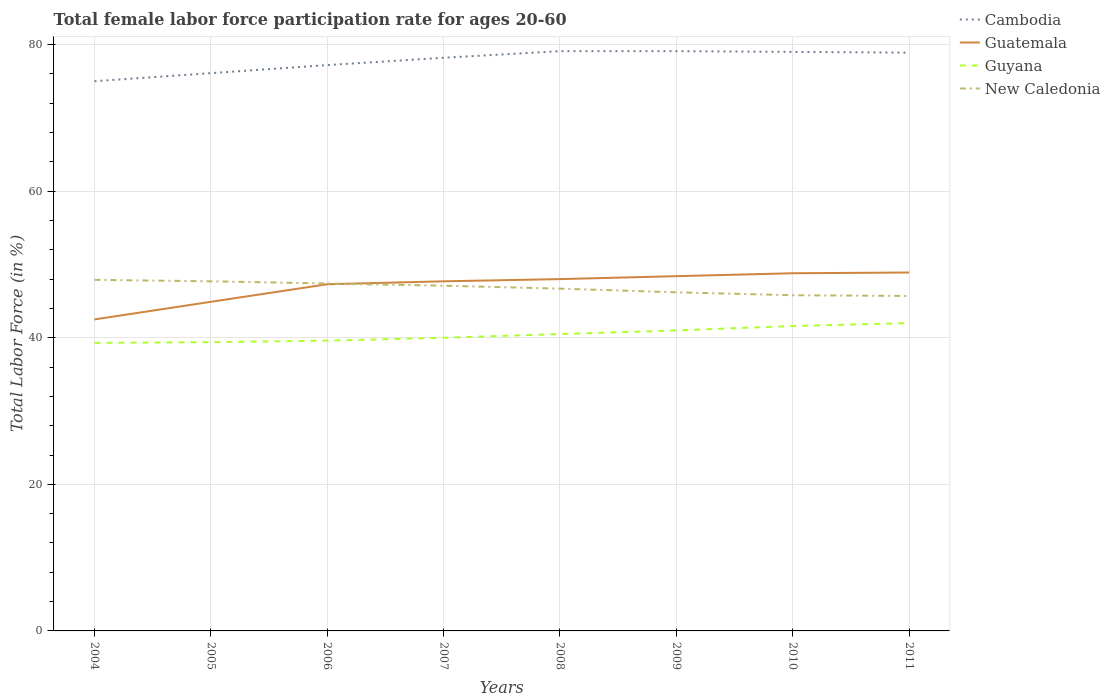Is the number of lines equal to the number of legend labels?
Give a very brief answer. Yes. Across all years, what is the maximum female labor force participation rate in Cambodia?
Make the answer very short. 75. What is the difference between the highest and the second highest female labor force participation rate in New Caledonia?
Your response must be concise. 2.2. What is the difference between the highest and the lowest female labor force participation rate in Guyana?
Offer a very short reply. 4. Is the female labor force participation rate in Guatemala strictly greater than the female labor force participation rate in Guyana over the years?
Your answer should be compact. No. How many lines are there?
Keep it short and to the point. 4. How many years are there in the graph?
Make the answer very short. 8. What is the difference between two consecutive major ticks on the Y-axis?
Keep it short and to the point. 20. Are the values on the major ticks of Y-axis written in scientific E-notation?
Offer a terse response. No. Does the graph contain grids?
Your answer should be very brief. Yes. Where does the legend appear in the graph?
Your answer should be compact. Top right. What is the title of the graph?
Keep it short and to the point. Total female labor force participation rate for ages 20-60. Does "Central Europe" appear as one of the legend labels in the graph?
Make the answer very short. No. What is the Total Labor Force (in %) in Cambodia in 2004?
Provide a succinct answer. 75. What is the Total Labor Force (in %) of Guatemala in 2004?
Offer a terse response. 42.5. What is the Total Labor Force (in %) in Guyana in 2004?
Make the answer very short. 39.3. What is the Total Labor Force (in %) of New Caledonia in 2004?
Offer a terse response. 47.9. What is the Total Labor Force (in %) in Cambodia in 2005?
Keep it short and to the point. 76.1. What is the Total Labor Force (in %) of Guatemala in 2005?
Your response must be concise. 44.9. What is the Total Labor Force (in %) in Guyana in 2005?
Ensure brevity in your answer.  39.4. What is the Total Labor Force (in %) in New Caledonia in 2005?
Your answer should be very brief. 47.7. What is the Total Labor Force (in %) of Cambodia in 2006?
Your answer should be very brief. 77.2. What is the Total Labor Force (in %) in Guatemala in 2006?
Your answer should be compact. 47.3. What is the Total Labor Force (in %) in Guyana in 2006?
Your answer should be compact. 39.6. What is the Total Labor Force (in %) of New Caledonia in 2006?
Offer a terse response. 47.4. What is the Total Labor Force (in %) of Cambodia in 2007?
Offer a terse response. 78.2. What is the Total Labor Force (in %) of Guatemala in 2007?
Your response must be concise. 47.7. What is the Total Labor Force (in %) in New Caledonia in 2007?
Provide a succinct answer. 47.1. What is the Total Labor Force (in %) in Cambodia in 2008?
Ensure brevity in your answer.  79.1. What is the Total Labor Force (in %) of Guatemala in 2008?
Make the answer very short. 48. What is the Total Labor Force (in %) in Guyana in 2008?
Your answer should be very brief. 40.5. What is the Total Labor Force (in %) of New Caledonia in 2008?
Provide a short and direct response. 46.7. What is the Total Labor Force (in %) in Cambodia in 2009?
Ensure brevity in your answer.  79.1. What is the Total Labor Force (in %) of Guatemala in 2009?
Give a very brief answer. 48.4. What is the Total Labor Force (in %) of New Caledonia in 2009?
Provide a short and direct response. 46.2. What is the Total Labor Force (in %) in Cambodia in 2010?
Offer a very short reply. 79. What is the Total Labor Force (in %) of Guatemala in 2010?
Provide a short and direct response. 48.8. What is the Total Labor Force (in %) in Guyana in 2010?
Your answer should be compact. 41.6. What is the Total Labor Force (in %) of New Caledonia in 2010?
Your answer should be compact. 45.8. What is the Total Labor Force (in %) in Cambodia in 2011?
Provide a succinct answer. 78.9. What is the Total Labor Force (in %) of Guatemala in 2011?
Make the answer very short. 48.9. What is the Total Labor Force (in %) of Guyana in 2011?
Your answer should be compact. 42. What is the Total Labor Force (in %) in New Caledonia in 2011?
Provide a succinct answer. 45.7. Across all years, what is the maximum Total Labor Force (in %) in Cambodia?
Your answer should be very brief. 79.1. Across all years, what is the maximum Total Labor Force (in %) in Guatemala?
Offer a very short reply. 48.9. Across all years, what is the maximum Total Labor Force (in %) of Guyana?
Provide a succinct answer. 42. Across all years, what is the maximum Total Labor Force (in %) in New Caledonia?
Your answer should be very brief. 47.9. Across all years, what is the minimum Total Labor Force (in %) in Cambodia?
Provide a succinct answer. 75. Across all years, what is the minimum Total Labor Force (in %) in Guatemala?
Your answer should be very brief. 42.5. Across all years, what is the minimum Total Labor Force (in %) in Guyana?
Your answer should be very brief. 39.3. Across all years, what is the minimum Total Labor Force (in %) of New Caledonia?
Your answer should be compact. 45.7. What is the total Total Labor Force (in %) in Cambodia in the graph?
Provide a short and direct response. 622.6. What is the total Total Labor Force (in %) of Guatemala in the graph?
Provide a succinct answer. 376.5. What is the total Total Labor Force (in %) of Guyana in the graph?
Provide a succinct answer. 323.4. What is the total Total Labor Force (in %) in New Caledonia in the graph?
Offer a terse response. 374.5. What is the difference between the Total Labor Force (in %) of Guyana in 2004 and that in 2005?
Offer a very short reply. -0.1. What is the difference between the Total Labor Force (in %) in New Caledonia in 2004 and that in 2005?
Your response must be concise. 0.2. What is the difference between the Total Labor Force (in %) in Cambodia in 2004 and that in 2006?
Give a very brief answer. -2.2. What is the difference between the Total Labor Force (in %) in New Caledonia in 2004 and that in 2007?
Offer a very short reply. 0.8. What is the difference between the Total Labor Force (in %) of Guatemala in 2004 and that in 2008?
Your response must be concise. -5.5. What is the difference between the Total Labor Force (in %) in New Caledonia in 2004 and that in 2008?
Provide a short and direct response. 1.2. What is the difference between the Total Labor Force (in %) of Cambodia in 2004 and that in 2009?
Provide a succinct answer. -4.1. What is the difference between the Total Labor Force (in %) of Cambodia in 2004 and that in 2010?
Your answer should be compact. -4. What is the difference between the Total Labor Force (in %) in New Caledonia in 2004 and that in 2010?
Ensure brevity in your answer.  2.1. What is the difference between the Total Labor Force (in %) of Cambodia in 2004 and that in 2011?
Ensure brevity in your answer.  -3.9. What is the difference between the Total Labor Force (in %) in Guatemala in 2004 and that in 2011?
Offer a terse response. -6.4. What is the difference between the Total Labor Force (in %) in New Caledonia in 2004 and that in 2011?
Offer a very short reply. 2.2. What is the difference between the Total Labor Force (in %) in Guatemala in 2005 and that in 2006?
Offer a very short reply. -2.4. What is the difference between the Total Labor Force (in %) in Guyana in 2005 and that in 2006?
Your response must be concise. -0.2. What is the difference between the Total Labor Force (in %) of New Caledonia in 2005 and that in 2007?
Make the answer very short. 0.6. What is the difference between the Total Labor Force (in %) in Cambodia in 2005 and that in 2008?
Provide a succinct answer. -3. What is the difference between the Total Labor Force (in %) in Guyana in 2005 and that in 2008?
Your response must be concise. -1.1. What is the difference between the Total Labor Force (in %) of Guatemala in 2005 and that in 2009?
Provide a succinct answer. -3.5. What is the difference between the Total Labor Force (in %) of Guyana in 2005 and that in 2009?
Ensure brevity in your answer.  -1.6. What is the difference between the Total Labor Force (in %) of New Caledonia in 2005 and that in 2009?
Provide a short and direct response. 1.5. What is the difference between the Total Labor Force (in %) in Guatemala in 2005 and that in 2010?
Your answer should be very brief. -3.9. What is the difference between the Total Labor Force (in %) in New Caledonia in 2005 and that in 2010?
Your response must be concise. 1.9. What is the difference between the Total Labor Force (in %) of Cambodia in 2005 and that in 2011?
Provide a short and direct response. -2.8. What is the difference between the Total Labor Force (in %) of New Caledonia in 2005 and that in 2011?
Make the answer very short. 2. What is the difference between the Total Labor Force (in %) of Guatemala in 2006 and that in 2007?
Ensure brevity in your answer.  -0.4. What is the difference between the Total Labor Force (in %) in Cambodia in 2006 and that in 2008?
Offer a terse response. -1.9. What is the difference between the Total Labor Force (in %) of Cambodia in 2006 and that in 2009?
Give a very brief answer. -1.9. What is the difference between the Total Labor Force (in %) in Guatemala in 2006 and that in 2009?
Offer a terse response. -1.1. What is the difference between the Total Labor Force (in %) in New Caledonia in 2006 and that in 2009?
Ensure brevity in your answer.  1.2. What is the difference between the Total Labor Force (in %) of Cambodia in 2006 and that in 2010?
Give a very brief answer. -1.8. What is the difference between the Total Labor Force (in %) in Guatemala in 2006 and that in 2010?
Provide a succinct answer. -1.5. What is the difference between the Total Labor Force (in %) of Guyana in 2006 and that in 2010?
Offer a terse response. -2. What is the difference between the Total Labor Force (in %) in Cambodia in 2006 and that in 2011?
Provide a succinct answer. -1.7. What is the difference between the Total Labor Force (in %) in Guatemala in 2006 and that in 2011?
Your answer should be compact. -1.6. What is the difference between the Total Labor Force (in %) in Cambodia in 2007 and that in 2009?
Your answer should be very brief. -0.9. What is the difference between the Total Labor Force (in %) in Guatemala in 2007 and that in 2009?
Give a very brief answer. -0.7. What is the difference between the Total Labor Force (in %) of Guyana in 2007 and that in 2009?
Provide a short and direct response. -1. What is the difference between the Total Labor Force (in %) in New Caledonia in 2007 and that in 2010?
Your answer should be compact. 1.3. What is the difference between the Total Labor Force (in %) of Guyana in 2008 and that in 2010?
Give a very brief answer. -1.1. What is the difference between the Total Labor Force (in %) in Cambodia in 2008 and that in 2011?
Your answer should be compact. 0.2. What is the difference between the Total Labor Force (in %) of New Caledonia in 2008 and that in 2011?
Your answer should be compact. 1. What is the difference between the Total Labor Force (in %) in Cambodia in 2009 and that in 2010?
Make the answer very short. 0.1. What is the difference between the Total Labor Force (in %) of Cambodia in 2009 and that in 2011?
Make the answer very short. 0.2. What is the difference between the Total Labor Force (in %) in Guyana in 2009 and that in 2011?
Your response must be concise. -1. What is the difference between the Total Labor Force (in %) in Cambodia in 2010 and that in 2011?
Ensure brevity in your answer.  0.1. What is the difference between the Total Labor Force (in %) of Cambodia in 2004 and the Total Labor Force (in %) of Guatemala in 2005?
Give a very brief answer. 30.1. What is the difference between the Total Labor Force (in %) of Cambodia in 2004 and the Total Labor Force (in %) of Guyana in 2005?
Your response must be concise. 35.6. What is the difference between the Total Labor Force (in %) of Cambodia in 2004 and the Total Labor Force (in %) of New Caledonia in 2005?
Ensure brevity in your answer.  27.3. What is the difference between the Total Labor Force (in %) in Guatemala in 2004 and the Total Labor Force (in %) in Guyana in 2005?
Make the answer very short. 3.1. What is the difference between the Total Labor Force (in %) of Cambodia in 2004 and the Total Labor Force (in %) of Guatemala in 2006?
Ensure brevity in your answer.  27.7. What is the difference between the Total Labor Force (in %) of Cambodia in 2004 and the Total Labor Force (in %) of Guyana in 2006?
Give a very brief answer. 35.4. What is the difference between the Total Labor Force (in %) in Cambodia in 2004 and the Total Labor Force (in %) in New Caledonia in 2006?
Give a very brief answer. 27.6. What is the difference between the Total Labor Force (in %) of Guatemala in 2004 and the Total Labor Force (in %) of Guyana in 2006?
Provide a short and direct response. 2.9. What is the difference between the Total Labor Force (in %) in Cambodia in 2004 and the Total Labor Force (in %) in Guatemala in 2007?
Make the answer very short. 27.3. What is the difference between the Total Labor Force (in %) in Cambodia in 2004 and the Total Labor Force (in %) in Guyana in 2007?
Provide a short and direct response. 35. What is the difference between the Total Labor Force (in %) in Cambodia in 2004 and the Total Labor Force (in %) in New Caledonia in 2007?
Make the answer very short. 27.9. What is the difference between the Total Labor Force (in %) of Cambodia in 2004 and the Total Labor Force (in %) of Guatemala in 2008?
Offer a very short reply. 27. What is the difference between the Total Labor Force (in %) of Cambodia in 2004 and the Total Labor Force (in %) of Guyana in 2008?
Ensure brevity in your answer.  34.5. What is the difference between the Total Labor Force (in %) in Cambodia in 2004 and the Total Labor Force (in %) in New Caledonia in 2008?
Provide a short and direct response. 28.3. What is the difference between the Total Labor Force (in %) of Guatemala in 2004 and the Total Labor Force (in %) of Guyana in 2008?
Make the answer very short. 2. What is the difference between the Total Labor Force (in %) in Guyana in 2004 and the Total Labor Force (in %) in New Caledonia in 2008?
Provide a short and direct response. -7.4. What is the difference between the Total Labor Force (in %) in Cambodia in 2004 and the Total Labor Force (in %) in Guatemala in 2009?
Your answer should be very brief. 26.6. What is the difference between the Total Labor Force (in %) of Cambodia in 2004 and the Total Labor Force (in %) of Guyana in 2009?
Your answer should be compact. 34. What is the difference between the Total Labor Force (in %) in Cambodia in 2004 and the Total Labor Force (in %) in New Caledonia in 2009?
Make the answer very short. 28.8. What is the difference between the Total Labor Force (in %) of Guyana in 2004 and the Total Labor Force (in %) of New Caledonia in 2009?
Offer a very short reply. -6.9. What is the difference between the Total Labor Force (in %) of Cambodia in 2004 and the Total Labor Force (in %) of Guatemala in 2010?
Keep it short and to the point. 26.2. What is the difference between the Total Labor Force (in %) in Cambodia in 2004 and the Total Labor Force (in %) in Guyana in 2010?
Provide a short and direct response. 33.4. What is the difference between the Total Labor Force (in %) of Cambodia in 2004 and the Total Labor Force (in %) of New Caledonia in 2010?
Make the answer very short. 29.2. What is the difference between the Total Labor Force (in %) in Guatemala in 2004 and the Total Labor Force (in %) in New Caledonia in 2010?
Offer a terse response. -3.3. What is the difference between the Total Labor Force (in %) in Guyana in 2004 and the Total Labor Force (in %) in New Caledonia in 2010?
Make the answer very short. -6.5. What is the difference between the Total Labor Force (in %) in Cambodia in 2004 and the Total Labor Force (in %) in Guatemala in 2011?
Provide a short and direct response. 26.1. What is the difference between the Total Labor Force (in %) of Cambodia in 2004 and the Total Labor Force (in %) of New Caledonia in 2011?
Provide a short and direct response. 29.3. What is the difference between the Total Labor Force (in %) of Guatemala in 2004 and the Total Labor Force (in %) of Guyana in 2011?
Offer a terse response. 0.5. What is the difference between the Total Labor Force (in %) in Guatemala in 2004 and the Total Labor Force (in %) in New Caledonia in 2011?
Your answer should be compact. -3.2. What is the difference between the Total Labor Force (in %) of Guyana in 2004 and the Total Labor Force (in %) of New Caledonia in 2011?
Give a very brief answer. -6.4. What is the difference between the Total Labor Force (in %) of Cambodia in 2005 and the Total Labor Force (in %) of Guatemala in 2006?
Provide a short and direct response. 28.8. What is the difference between the Total Labor Force (in %) of Cambodia in 2005 and the Total Labor Force (in %) of Guyana in 2006?
Give a very brief answer. 36.5. What is the difference between the Total Labor Force (in %) in Cambodia in 2005 and the Total Labor Force (in %) in New Caledonia in 2006?
Offer a very short reply. 28.7. What is the difference between the Total Labor Force (in %) of Guatemala in 2005 and the Total Labor Force (in %) of Guyana in 2006?
Keep it short and to the point. 5.3. What is the difference between the Total Labor Force (in %) of Cambodia in 2005 and the Total Labor Force (in %) of Guatemala in 2007?
Provide a short and direct response. 28.4. What is the difference between the Total Labor Force (in %) of Cambodia in 2005 and the Total Labor Force (in %) of Guyana in 2007?
Provide a short and direct response. 36.1. What is the difference between the Total Labor Force (in %) in Guatemala in 2005 and the Total Labor Force (in %) in New Caledonia in 2007?
Your answer should be very brief. -2.2. What is the difference between the Total Labor Force (in %) of Guyana in 2005 and the Total Labor Force (in %) of New Caledonia in 2007?
Your answer should be compact. -7.7. What is the difference between the Total Labor Force (in %) in Cambodia in 2005 and the Total Labor Force (in %) in Guatemala in 2008?
Your response must be concise. 28.1. What is the difference between the Total Labor Force (in %) of Cambodia in 2005 and the Total Labor Force (in %) of Guyana in 2008?
Make the answer very short. 35.6. What is the difference between the Total Labor Force (in %) in Cambodia in 2005 and the Total Labor Force (in %) in New Caledonia in 2008?
Give a very brief answer. 29.4. What is the difference between the Total Labor Force (in %) in Guatemala in 2005 and the Total Labor Force (in %) in Guyana in 2008?
Provide a succinct answer. 4.4. What is the difference between the Total Labor Force (in %) in Guatemala in 2005 and the Total Labor Force (in %) in New Caledonia in 2008?
Ensure brevity in your answer.  -1.8. What is the difference between the Total Labor Force (in %) in Guyana in 2005 and the Total Labor Force (in %) in New Caledonia in 2008?
Provide a short and direct response. -7.3. What is the difference between the Total Labor Force (in %) of Cambodia in 2005 and the Total Labor Force (in %) of Guatemala in 2009?
Offer a very short reply. 27.7. What is the difference between the Total Labor Force (in %) in Cambodia in 2005 and the Total Labor Force (in %) in Guyana in 2009?
Make the answer very short. 35.1. What is the difference between the Total Labor Force (in %) in Cambodia in 2005 and the Total Labor Force (in %) in New Caledonia in 2009?
Ensure brevity in your answer.  29.9. What is the difference between the Total Labor Force (in %) in Guatemala in 2005 and the Total Labor Force (in %) in Guyana in 2009?
Provide a short and direct response. 3.9. What is the difference between the Total Labor Force (in %) in Guatemala in 2005 and the Total Labor Force (in %) in New Caledonia in 2009?
Provide a succinct answer. -1.3. What is the difference between the Total Labor Force (in %) in Guyana in 2005 and the Total Labor Force (in %) in New Caledonia in 2009?
Provide a short and direct response. -6.8. What is the difference between the Total Labor Force (in %) in Cambodia in 2005 and the Total Labor Force (in %) in Guatemala in 2010?
Ensure brevity in your answer.  27.3. What is the difference between the Total Labor Force (in %) in Cambodia in 2005 and the Total Labor Force (in %) in Guyana in 2010?
Your answer should be compact. 34.5. What is the difference between the Total Labor Force (in %) of Cambodia in 2005 and the Total Labor Force (in %) of New Caledonia in 2010?
Offer a very short reply. 30.3. What is the difference between the Total Labor Force (in %) of Guatemala in 2005 and the Total Labor Force (in %) of New Caledonia in 2010?
Your answer should be very brief. -0.9. What is the difference between the Total Labor Force (in %) of Cambodia in 2005 and the Total Labor Force (in %) of Guatemala in 2011?
Ensure brevity in your answer.  27.2. What is the difference between the Total Labor Force (in %) in Cambodia in 2005 and the Total Labor Force (in %) in Guyana in 2011?
Keep it short and to the point. 34.1. What is the difference between the Total Labor Force (in %) of Cambodia in 2005 and the Total Labor Force (in %) of New Caledonia in 2011?
Offer a very short reply. 30.4. What is the difference between the Total Labor Force (in %) of Guatemala in 2005 and the Total Labor Force (in %) of New Caledonia in 2011?
Make the answer very short. -0.8. What is the difference between the Total Labor Force (in %) of Guyana in 2005 and the Total Labor Force (in %) of New Caledonia in 2011?
Keep it short and to the point. -6.3. What is the difference between the Total Labor Force (in %) in Cambodia in 2006 and the Total Labor Force (in %) in Guatemala in 2007?
Keep it short and to the point. 29.5. What is the difference between the Total Labor Force (in %) of Cambodia in 2006 and the Total Labor Force (in %) of Guyana in 2007?
Your answer should be very brief. 37.2. What is the difference between the Total Labor Force (in %) in Cambodia in 2006 and the Total Labor Force (in %) in New Caledonia in 2007?
Offer a very short reply. 30.1. What is the difference between the Total Labor Force (in %) in Guatemala in 2006 and the Total Labor Force (in %) in Guyana in 2007?
Give a very brief answer. 7.3. What is the difference between the Total Labor Force (in %) of Cambodia in 2006 and the Total Labor Force (in %) of Guatemala in 2008?
Your answer should be very brief. 29.2. What is the difference between the Total Labor Force (in %) in Cambodia in 2006 and the Total Labor Force (in %) in Guyana in 2008?
Offer a terse response. 36.7. What is the difference between the Total Labor Force (in %) in Cambodia in 2006 and the Total Labor Force (in %) in New Caledonia in 2008?
Provide a short and direct response. 30.5. What is the difference between the Total Labor Force (in %) in Guyana in 2006 and the Total Labor Force (in %) in New Caledonia in 2008?
Offer a very short reply. -7.1. What is the difference between the Total Labor Force (in %) of Cambodia in 2006 and the Total Labor Force (in %) of Guatemala in 2009?
Your answer should be very brief. 28.8. What is the difference between the Total Labor Force (in %) in Cambodia in 2006 and the Total Labor Force (in %) in Guyana in 2009?
Your response must be concise. 36.2. What is the difference between the Total Labor Force (in %) in Cambodia in 2006 and the Total Labor Force (in %) in New Caledonia in 2009?
Your response must be concise. 31. What is the difference between the Total Labor Force (in %) of Guatemala in 2006 and the Total Labor Force (in %) of Guyana in 2009?
Your response must be concise. 6.3. What is the difference between the Total Labor Force (in %) of Guatemala in 2006 and the Total Labor Force (in %) of New Caledonia in 2009?
Give a very brief answer. 1.1. What is the difference between the Total Labor Force (in %) of Cambodia in 2006 and the Total Labor Force (in %) of Guatemala in 2010?
Ensure brevity in your answer.  28.4. What is the difference between the Total Labor Force (in %) of Cambodia in 2006 and the Total Labor Force (in %) of Guyana in 2010?
Ensure brevity in your answer.  35.6. What is the difference between the Total Labor Force (in %) in Cambodia in 2006 and the Total Labor Force (in %) in New Caledonia in 2010?
Offer a very short reply. 31.4. What is the difference between the Total Labor Force (in %) of Guatemala in 2006 and the Total Labor Force (in %) of Guyana in 2010?
Your answer should be very brief. 5.7. What is the difference between the Total Labor Force (in %) of Cambodia in 2006 and the Total Labor Force (in %) of Guatemala in 2011?
Provide a short and direct response. 28.3. What is the difference between the Total Labor Force (in %) of Cambodia in 2006 and the Total Labor Force (in %) of Guyana in 2011?
Offer a very short reply. 35.2. What is the difference between the Total Labor Force (in %) in Cambodia in 2006 and the Total Labor Force (in %) in New Caledonia in 2011?
Keep it short and to the point. 31.5. What is the difference between the Total Labor Force (in %) in Guatemala in 2006 and the Total Labor Force (in %) in Guyana in 2011?
Your answer should be compact. 5.3. What is the difference between the Total Labor Force (in %) in Cambodia in 2007 and the Total Labor Force (in %) in Guatemala in 2008?
Give a very brief answer. 30.2. What is the difference between the Total Labor Force (in %) of Cambodia in 2007 and the Total Labor Force (in %) of Guyana in 2008?
Offer a terse response. 37.7. What is the difference between the Total Labor Force (in %) of Cambodia in 2007 and the Total Labor Force (in %) of New Caledonia in 2008?
Keep it short and to the point. 31.5. What is the difference between the Total Labor Force (in %) of Guatemala in 2007 and the Total Labor Force (in %) of Guyana in 2008?
Your answer should be compact. 7.2. What is the difference between the Total Labor Force (in %) of Cambodia in 2007 and the Total Labor Force (in %) of Guatemala in 2009?
Ensure brevity in your answer.  29.8. What is the difference between the Total Labor Force (in %) of Cambodia in 2007 and the Total Labor Force (in %) of Guyana in 2009?
Your answer should be very brief. 37.2. What is the difference between the Total Labor Force (in %) in Cambodia in 2007 and the Total Labor Force (in %) in New Caledonia in 2009?
Offer a terse response. 32. What is the difference between the Total Labor Force (in %) of Guatemala in 2007 and the Total Labor Force (in %) of Guyana in 2009?
Make the answer very short. 6.7. What is the difference between the Total Labor Force (in %) in Cambodia in 2007 and the Total Labor Force (in %) in Guatemala in 2010?
Provide a short and direct response. 29.4. What is the difference between the Total Labor Force (in %) in Cambodia in 2007 and the Total Labor Force (in %) in Guyana in 2010?
Your answer should be very brief. 36.6. What is the difference between the Total Labor Force (in %) in Cambodia in 2007 and the Total Labor Force (in %) in New Caledonia in 2010?
Your answer should be compact. 32.4. What is the difference between the Total Labor Force (in %) of Guatemala in 2007 and the Total Labor Force (in %) of New Caledonia in 2010?
Offer a very short reply. 1.9. What is the difference between the Total Labor Force (in %) of Cambodia in 2007 and the Total Labor Force (in %) of Guatemala in 2011?
Ensure brevity in your answer.  29.3. What is the difference between the Total Labor Force (in %) of Cambodia in 2007 and the Total Labor Force (in %) of Guyana in 2011?
Your answer should be very brief. 36.2. What is the difference between the Total Labor Force (in %) of Cambodia in 2007 and the Total Labor Force (in %) of New Caledonia in 2011?
Offer a very short reply. 32.5. What is the difference between the Total Labor Force (in %) of Guatemala in 2007 and the Total Labor Force (in %) of New Caledonia in 2011?
Your response must be concise. 2. What is the difference between the Total Labor Force (in %) of Guyana in 2007 and the Total Labor Force (in %) of New Caledonia in 2011?
Keep it short and to the point. -5.7. What is the difference between the Total Labor Force (in %) in Cambodia in 2008 and the Total Labor Force (in %) in Guatemala in 2009?
Offer a terse response. 30.7. What is the difference between the Total Labor Force (in %) of Cambodia in 2008 and the Total Labor Force (in %) of Guyana in 2009?
Provide a succinct answer. 38.1. What is the difference between the Total Labor Force (in %) of Cambodia in 2008 and the Total Labor Force (in %) of New Caledonia in 2009?
Offer a very short reply. 32.9. What is the difference between the Total Labor Force (in %) of Guatemala in 2008 and the Total Labor Force (in %) of Guyana in 2009?
Provide a succinct answer. 7. What is the difference between the Total Labor Force (in %) of Guyana in 2008 and the Total Labor Force (in %) of New Caledonia in 2009?
Your response must be concise. -5.7. What is the difference between the Total Labor Force (in %) in Cambodia in 2008 and the Total Labor Force (in %) in Guatemala in 2010?
Offer a terse response. 30.3. What is the difference between the Total Labor Force (in %) of Cambodia in 2008 and the Total Labor Force (in %) of Guyana in 2010?
Ensure brevity in your answer.  37.5. What is the difference between the Total Labor Force (in %) in Cambodia in 2008 and the Total Labor Force (in %) in New Caledonia in 2010?
Provide a succinct answer. 33.3. What is the difference between the Total Labor Force (in %) of Cambodia in 2008 and the Total Labor Force (in %) of Guatemala in 2011?
Give a very brief answer. 30.2. What is the difference between the Total Labor Force (in %) of Cambodia in 2008 and the Total Labor Force (in %) of Guyana in 2011?
Your response must be concise. 37.1. What is the difference between the Total Labor Force (in %) of Cambodia in 2008 and the Total Labor Force (in %) of New Caledonia in 2011?
Provide a succinct answer. 33.4. What is the difference between the Total Labor Force (in %) in Guatemala in 2008 and the Total Labor Force (in %) in Guyana in 2011?
Your answer should be compact. 6. What is the difference between the Total Labor Force (in %) of Guatemala in 2008 and the Total Labor Force (in %) of New Caledonia in 2011?
Provide a succinct answer. 2.3. What is the difference between the Total Labor Force (in %) of Guyana in 2008 and the Total Labor Force (in %) of New Caledonia in 2011?
Your answer should be very brief. -5.2. What is the difference between the Total Labor Force (in %) in Cambodia in 2009 and the Total Labor Force (in %) in Guatemala in 2010?
Your answer should be compact. 30.3. What is the difference between the Total Labor Force (in %) in Cambodia in 2009 and the Total Labor Force (in %) in Guyana in 2010?
Your answer should be compact. 37.5. What is the difference between the Total Labor Force (in %) in Cambodia in 2009 and the Total Labor Force (in %) in New Caledonia in 2010?
Your answer should be compact. 33.3. What is the difference between the Total Labor Force (in %) in Guatemala in 2009 and the Total Labor Force (in %) in Guyana in 2010?
Make the answer very short. 6.8. What is the difference between the Total Labor Force (in %) of Cambodia in 2009 and the Total Labor Force (in %) of Guatemala in 2011?
Give a very brief answer. 30.2. What is the difference between the Total Labor Force (in %) in Cambodia in 2009 and the Total Labor Force (in %) in Guyana in 2011?
Your answer should be very brief. 37.1. What is the difference between the Total Labor Force (in %) of Cambodia in 2009 and the Total Labor Force (in %) of New Caledonia in 2011?
Provide a succinct answer. 33.4. What is the difference between the Total Labor Force (in %) in Guatemala in 2009 and the Total Labor Force (in %) in New Caledonia in 2011?
Keep it short and to the point. 2.7. What is the difference between the Total Labor Force (in %) in Cambodia in 2010 and the Total Labor Force (in %) in Guatemala in 2011?
Provide a short and direct response. 30.1. What is the difference between the Total Labor Force (in %) in Cambodia in 2010 and the Total Labor Force (in %) in Guyana in 2011?
Offer a very short reply. 37. What is the difference between the Total Labor Force (in %) of Cambodia in 2010 and the Total Labor Force (in %) of New Caledonia in 2011?
Offer a terse response. 33.3. What is the difference between the Total Labor Force (in %) of Guatemala in 2010 and the Total Labor Force (in %) of Guyana in 2011?
Offer a terse response. 6.8. What is the difference between the Total Labor Force (in %) in Guyana in 2010 and the Total Labor Force (in %) in New Caledonia in 2011?
Your answer should be compact. -4.1. What is the average Total Labor Force (in %) of Cambodia per year?
Offer a terse response. 77.83. What is the average Total Labor Force (in %) in Guatemala per year?
Ensure brevity in your answer.  47.06. What is the average Total Labor Force (in %) in Guyana per year?
Your answer should be very brief. 40.42. What is the average Total Labor Force (in %) in New Caledonia per year?
Make the answer very short. 46.81. In the year 2004, what is the difference between the Total Labor Force (in %) of Cambodia and Total Labor Force (in %) of Guatemala?
Provide a succinct answer. 32.5. In the year 2004, what is the difference between the Total Labor Force (in %) of Cambodia and Total Labor Force (in %) of Guyana?
Your answer should be compact. 35.7. In the year 2004, what is the difference between the Total Labor Force (in %) in Cambodia and Total Labor Force (in %) in New Caledonia?
Offer a very short reply. 27.1. In the year 2004, what is the difference between the Total Labor Force (in %) of Guatemala and Total Labor Force (in %) of Guyana?
Your answer should be compact. 3.2. In the year 2004, what is the difference between the Total Labor Force (in %) of Guyana and Total Labor Force (in %) of New Caledonia?
Offer a very short reply. -8.6. In the year 2005, what is the difference between the Total Labor Force (in %) of Cambodia and Total Labor Force (in %) of Guatemala?
Keep it short and to the point. 31.2. In the year 2005, what is the difference between the Total Labor Force (in %) in Cambodia and Total Labor Force (in %) in Guyana?
Make the answer very short. 36.7. In the year 2005, what is the difference between the Total Labor Force (in %) in Cambodia and Total Labor Force (in %) in New Caledonia?
Give a very brief answer. 28.4. In the year 2005, what is the difference between the Total Labor Force (in %) in Guatemala and Total Labor Force (in %) in Guyana?
Offer a very short reply. 5.5. In the year 2006, what is the difference between the Total Labor Force (in %) in Cambodia and Total Labor Force (in %) in Guatemala?
Give a very brief answer. 29.9. In the year 2006, what is the difference between the Total Labor Force (in %) of Cambodia and Total Labor Force (in %) of Guyana?
Make the answer very short. 37.6. In the year 2006, what is the difference between the Total Labor Force (in %) in Cambodia and Total Labor Force (in %) in New Caledonia?
Make the answer very short. 29.8. In the year 2006, what is the difference between the Total Labor Force (in %) of Guatemala and Total Labor Force (in %) of Guyana?
Offer a very short reply. 7.7. In the year 2006, what is the difference between the Total Labor Force (in %) of Guatemala and Total Labor Force (in %) of New Caledonia?
Provide a succinct answer. -0.1. In the year 2006, what is the difference between the Total Labor Force (in %) in Guyana and Total Labor Force (in %) in New Caledonia?
Ensure brevity in your answer.  -7.8. In the year 2007, what is the difference between the Total Labor Force (in %) in Cambodia and Total Labor Force (in %) in Guatemala?
Your answer should be compact. 30.5. In the year 2007, what is the difference between the Total Labor Force (in %) in Cambodia and Total Labor Force (in %) in Guyana?
Provide a succinct answer. 38.2. In the year 2007, what is the difference between the Total Labor Force (in %) of Cambodia and Total Labor Force (in %) of New Caledonia?
Provide a short and direct response. 31.1. In the year 2007, what is the difference between the Total Labor Force (in %) in Guyana and Total Labor Force (in %) in New Caledonia?
Give a very brief answer. -7.1. In the year 2008, what is the difference between the Total Labor Force (in %) of Cambodia and Total Labor Force (in %) of Guatemala?
Make the answer very short. 31.1. In the year 2008, what is the difference between the Total Labor Force (in %) in Cambodia and Total Labor Force (in %) in Guyana?
Offer a terse response. 38.6. In the year 2008, what is the difference between the Total Labor Force (in %) in Cambodia and Total Labor Force (in %) in New Caledonia?
Your answer should be compact. 32.4. In the year 2009, what is the difference between the Total Labor Force (in %) in Cambodia and Total Labor Force (in %) in Guatemala?
Provide a short and direct response. 30.7. In the year 2009, what is the difference between the Total Labor Force (in %) of Cambodia and Total Labor Force (in %) of Guyana?
Give a very brief answer. 38.1. In the year 2009, what is the difference between the Total Labor Force (in %) of Cambodia and Total Labor Force (in %) of New Caledonia?
Your answer should be very brief. 32.9. In the year 2009, what is the difference between the Total Labor Force (in %) of Guatemala and Total Labor Force (in %) of Guyana?
Your answer should be very brief. 7.4. In the year 2009, what is the difference between the Total Labor Force (in %) of Guyana and Total Labor Force (in %) of New Caledonia?
Make the answer very short. -5.2. In the year 2010, what is the difference between the Total Labor Force (in %) in Cambodia and Total Labor Force (in %) in Guatemala?
Keep it short and to the point. 30.2. In the year 2010, what is the difference between the Total Labor Force (in %) in Cambodia and Total Labor Force (in %) in Guyana?
Offer a terse response. 37.4. In the year 2010, what is the difference between the Total Labor Force (in %) of Cambodia and Total Labor Force (in %) of New Caledonia?
Your answer should be compact. 33.2. In the year 2010, what is the difference between the Total Labor Force (in %) in Guatemala and Total Labor Force (in %) in Guyana?
Your answer should be compact. 7.2. In the year 2010, what is the difference between the Total Labor Force (in %) of Guyana and Total Labor Force (in %) of New Caledonia?
Provide a succinct answer. -4.2. In the year 2011, what is the difference between the Total Labor Force (in %) in Cambodia and Total Labor Force (in %) in Guatemala?
Your answer should be compact. 30. In the year 2011, what is the difference between the Total Labor Force (in %) in Cambodia and Total Labor Force (in %) in Guyana?
Your answer should be compact. 36.9. In the year 2011, what is the difference between the Total Labor Force (in %) in Cambodia and Total Labor Force (in %) in New Caledonia?
Your response must be concise. 33.2. In the year 2011, what is the difference between the Total Labor Force (in %) in Guatemala and Total Labor Force (in %) in New Caledonia?
Give a very brief answer. 3.2. In the year 2011, what is the difference between the Total Labor Force (in %) of Guyana and Total Labor Force (in %) of New Caledonia?
Provide a short and direct response. -3.7. What is the ratio of the Total Labor Force (in %) of Cambodia in 2004 to that in 2005?
Provide a short and direct response. 0.99. What is the ratio of the Total Labor Force (in %) in Guatemala in 2004 to that in 2005?
Keep it short and to the point. 0.95. What is the ratio of the Total Labor Force (in %) in New Caledonia in 2004 to that in 2005?
Offer a very short reply. 1. What is the ratio of the Total Labor Force (in %) in Cambodia in 2004 to that in 2006?
Your answer should be compact. 0.97. What is the ratio of the Total Labor Force (in %) in Guatemala in 2004 to that in 2006?
Your response must be concise. 0.9. What is the ratio of the Total Labor Force (in %) of Guyana in 2004 to that in 2006?
Offer a terse response. 0.99. What is the ratio of the Total Labor Force (in %) of New Caledonia in 2004 to that in 2006?
Ensure brevity in your answer.  1.01. What is the ratio of the Total Labor Force (in %) in Cambodia in 2004 to that in 2007?
Provide a short and direct response. 0.96. What is the ratio of the Total Labor Force (in %) of Guatemala in 2004 to that in 2007?
Offer a very short reply. 0.89. What is the ratio of the Total Labor Force (in %) in Guyana in 2004 to that in 2007?
Provide a succinct answer. 0.98. What is the ratio of the Total Labor Force (in %) in Cambodia in 2004 to that in 2008?
Your answer should be compact. 0.95. What is the ratio of the Total Labor Force (in %) of Guatemala in 2004 to that in 2008?
Make the answer very short. 0.89. What is the ratio of the Total Labor Force (in %) in Guyana in 2004 to that in 2008?
Provide a short and direct response. 0.97. What is the ratio of the Total Labor Force (in %) in New Caledonia in 2004 to that in 2008?
Ensure brevity in your answer.  1.03. What is the ratio of the Total Labor Force (in %) in Cambodia in 2004 to that in 2009?
Provide a short and direct response. 0.95. What is the ratio of the Total Labor Force (in %) of Guatemala in 2004 to that in 2009?
Ensure brevity in your answer.  0.88. What is the ratio of the Total Labor Force (in %) of Guyana in 2004 to that in 2009?
Your answer should be very brief. 0.96. What is the ratio of the Total Labor Force (in %) in New Caledonia in 2004 to that in 2009?
Your answer should be compact. 1.04. What is the ratio of the Total Labor Force (in %) in Cambodia in 2004 to that in 2010?
Give a very brief answer. 0.95. What is the ratio of the Total Labor Force (in %) of Guatemala in 2004 to that in 2010?
Provide a short and direct response. 0.87. What is the ratio of the Total Labor Force (in %) of Guyana in 2004 to that in 2010?
Your answer should be very brief. 0.94. What is the ratio of the Total Labor Force (in %) in New Caledonia in 2004 to that in 2010?
Make the answer very short. 1.05. What is the ratio of the Total Labor Force (in %) of Cambodia in 2004 to that in 2011?
Your response must be concise. 0.95. What is the ratio of the Total Labor Force (in %) of Guatemala in 2004 to that in 2011?
Ensure brevity in your answer.  0.87. What is the ratio of the Total Labor Force (in %) of Guyana in 2004 to that in 2011?
Your answer should be compact. 0.94. What is the ratio of the Total Labor Force (in %) of New Caledonia in 2004 to that in 2011?
Your answer should be very brief. 1.05. What is the ratio of the Total Labor Force (in %) of Cambodia in 2005 to that in 2006?
Your response must be concise. 0.99. What is the ratio of the Total Labor Force (in %) in Guatemala in 2005 to that in 2006?
Keep it short and to the point. 0.95. What is the ratio of the Total Labor Force (in %) in Guyana in 2005 to that in 2006?
Keep it short and to the point. 0.99. What is the ratio of the Total Labor Force (in %) in New Caledonia in 2005 to that in 2006?
Give a very brief answer. 1.01. What is the ratio of the Total Labor Force (in %) of Cambodia in 2005 to that in 2007?
Provide a short and direct response. 0.97. What is the ratio of the Total Labor Force (in %) of Guatemala in 2005 to that in 2007?
Your response must be concise. 0.94. What is the ratio of the Total Labor Force (in %) of Guyana in 2005 to that in 2007?
Your answer should be very brief. 0.98. What is the ratio of the Total Labor Force (in %) of New Caledonia in 2005 to that in 2007?
Make the answer very short. 1.01. What is the ratio of the Total Labor Force (in %) of Cambodia in 2005 to that in 2008?
Give a very brief answer. 0.96. What is the ratio of the Total Labor Force (in %) of Guatemala in 2005 to that in 2008?
Make the answer very short. 0.94. What is the ratio of the Total Labor Force (in %) in Guyana in 2005 to that in 2008?
Your answer should be compact. 0.97. What is the ratio of the Total Labor Force (in %) in New Caledonia in 2005 to that in 2008?
Offer a terse response. 1.02. What is the ratio of the Total Labor Force (in %) in Cambodia in 2005 to that in 2009?
Make the answer very short. 0.96. What is the ratio of the Total Labor Force (in %) in Guatemala in 2005 to that in 2009?
Give a very brief answer. 0.93. What is the ratio of the Total Labor Force (in %) of New Caledonia in 2005 to that in 2009?
Offer a terse response. 1.03. What is the ratio of the Total Labor Force (in %) of Cambodia in 2005 to that in 2010?
Provide a short and direct response. 0.96. What is the ratio of the Total Labor Force (in %) in Guatemala in 2005 to that in 2010?
Provide a short and direct response. 0.92. What is the ratio of the Total Labor Force (in %) in Guyana in 2005 to that in 2010?
Your response must be concise. 0.95. What is the ratio of the Total Labor Force (in %) of New Caledonia in 2005 to that in 2010?
Your answer should be compact. 1.04. What is the ratio of the Total Labor Force (in %) in Cambodia in 2005 to that in 2011?
Offer a terse response. 0.96. What is the ratio of the Total Labor Force (in %) in Guatemala in 2005 to that in 2011?
Give a very brief answer. 0.92. What is the ratio of the Total Labor Force (in %) in Guyana in 2005 to that in 2011?
Your answer should be compact. 0.94. What is the ratio of the Total Labor Force (in %) of New Caledonia in 2005 to that in 2011?
Offer a very short reply. 1.04. What is the ratio of the Total Labor Force (in %) of Cambodia in 2006 to that in 2007?
Provide a succinct answer. 0.99. What is the ratio of the Total Labor Force (in %) in Guatemala in 2006 to that in 2007?
Keep it short and to the point. 0.99. What is the ratio of the Total Labor Force (in %) in Guyana in 2006 to that in 2007?
Give a very brief answer. 0.99. What is the ratio of the Total Labor Force (in %) of New Caledonia in 2006 to that in 2007?
Provide a short and direct response. 1.01. What is the ratio of the Total Labor Force (in %) of Cambodia in 2006 to that in 2008?
Your answer should be compact. 0.98. What is the ratio of the Total Labor Force (in %) of Guatemala in 2006 to that in 2008?
Provide a succinct answer. 0.99. What is the ratio of the Total Labor Force (in %) in Guyana in 2006 to that in 2008?
Keep it short and to the point. 0.98. What is the ratio of the Total Labor Force (in %) in New Caledonia in 2006 to that in 2008?
Provide a short and direct response. 1.01. What is the ratio of the Total Labor Force (in %) in Guatemala in 2006 to that in 2009?
Make the answer very short. 0.98. What is the ratio of the Total Labor Force (in %) in Guyana in 2006 to that in 2009?
Provide a short and direct response. 0.97. What is the ratio of the Total Labor Force (in %) in Cambodia in 2006 to that in 2010?
Your answer should be very brief. 0.98. What is the ratio of the Total Labor Force (in %) in Guatemala in 2006 to that in 2010?
Offer a very short reply. 0.97. What is the ratio of the Total Labor Force (in %) of Guyana in 2006 to that in 2010?
Give a very brief answer. 0.95. What is the ratio of the Total Labor Force (in %) in New Caledonia in 2006 to that in 2010?
Your response must be concise. 1.03. What is the ratio of the Total Labor Force (in %) of Cambodia in 2006 to that in 2011?
Make the answer very short. 0.98. What is the ratio of the Total Labor Force (in %) in Guatemala in 2006 to that in 2011?
Provide a succinct answer. 0.97. What is the ratio of the Total Labor Force (in %) of Guyana in 2006 to that in 2011?
Your response must be concise. 0.94. What is the ratio of the Total Labor Force (in %) of New Caledonia in 2006 to that in 2011?
Your answer should be very brief. 1.04. What is the ratio of the Total Labor Force (in %) of Cambodia in 2007 to that in 2008?
Provide a short and direct response. 0.99. What is the ratio of the Total Labor Force (in %) of New Caledonia in 2007 to that in 2008?
Your answer should be compact. 1.01. What is the ratio of the Total Labor Force (in %) of Cambodia in 2007 to that in 2009?
Offer a terse response. 0.99. What is the ratio of the Total Labor Force (in %) of Guatemala in 2007 to that in 2009?
Make the answer very short. 0.99. What is the ratio of the Total Labor Force (in %) in Guyana in 2007 to that in 2009?
Offer a very short reply. 0.98. What is the ratio of the Total Labor Force (in %) of New Caledonia in 2007 to that in 2009?
Your answer should be very brief. 1.02. What is the ratio of the Total Labor Force (in %) of Cambodia in 2007 to that in 2010?
Make the answer very short. 0.99. What is the ratio of the Total Labor Force (in %) in Guatemala in 2007 to that in 2010?
Provide a succinct answer. 0.98. What is the ratio of the Total Labor Force (in %) of Guyana in 2007 to that in 2010?
Ensure brevity in your answer.  0.96. What is the ratio of the Total Labor Force (in %) in New Caledonia in 2007 to that in 2010?
Make the answer very short. 1.03. What is the ratio of the Total Labor Force (in %) in Cambodia in 2007 to that in 2011?
Your answer should be compact. 0.99. What is the ratio of the Total Labor Force (in %) of Guatemala in 2007 to that in 2011?
Make the answer very short. 0.98. What is the ratio of the Total Labor Force (in %) in Guyana in 2007 to that in 2011?
Give a very brief answer. 0.95. What is the ratio of the Total Labor Force (in %) of New Caledonia in 2007 to that in 2011?
Ensure brevity in your answer.  1.03. What is the ratio of the Total Labor Force (in %) of New Caledonia in 2008 to that in 2009?
Your response must be concise. 1.01. What is the ratio of the Total Labor Force (in %) in Cambodia in 2008 to that in 2010?
Provide a succinct answer. 1. What is the ratio of the Total Labor Force (in %) of Guatemala in 2008 to that in 2010?
Your answer should be very brief. 0.98. What is the ratio of the Total Labor Force (in %) in Guyana in 2008 to that in 2010?
Your answer should be very brief. 0.97. What is the ratio of the Total Labor Force (in %) in New Caledonia in 2008 to that in 2010?
Make the answer very short. 1.02. What is the ratio of the Total Labor Force (in %) of Guatemala in 2008 to that in 2011?
Keep it short and to the point. 0.98. What is the ratio of the Total Labor Force (in %) of New Caledonia in 2008 to that in 2011?
Ensure brevity in your answer.  1.02. What is the ratio of the Total Labor Force (in %) in Guyana in 2009 to that in 2010?
Your answer should be compact. 0.99. What is the ratio of the Total Labor Force (in %) in New Caledonia in 2009 to that in 2010?
Offer a terse response. 1.01. What is the ratio of the Total Labor Force (in %) in Guyana in 2009 to that in 2011?
Offer a terse response. 0.98. What is the ratio of the Total Labor Force (in %) in New Caledonia in 2009 to that in 2011?
Keep it short and to the point. 1.01. What is the ratio of the Total Labor Force (in %) in Cambodia in 2010 to that in 2011?
Give a very brief answer. 1. What is the ratio of the Total Labor Force (in %) in Guatemala in 2010 to that in 2011?
Your response must be concise. 1. What is the difference between the highest and the second highest Total Labor Force (in %) in Guatemala?
Provide a short and direct response. 0.1. What is the difference between the highest and the lowest Total Labor Force (in %) of Cambodia?
Offer a terse response. 4.1. What is the difference between the highest and the lowest Total Labor Force (in %) of Guyana?
Provide a succinct answer. 2.7. 